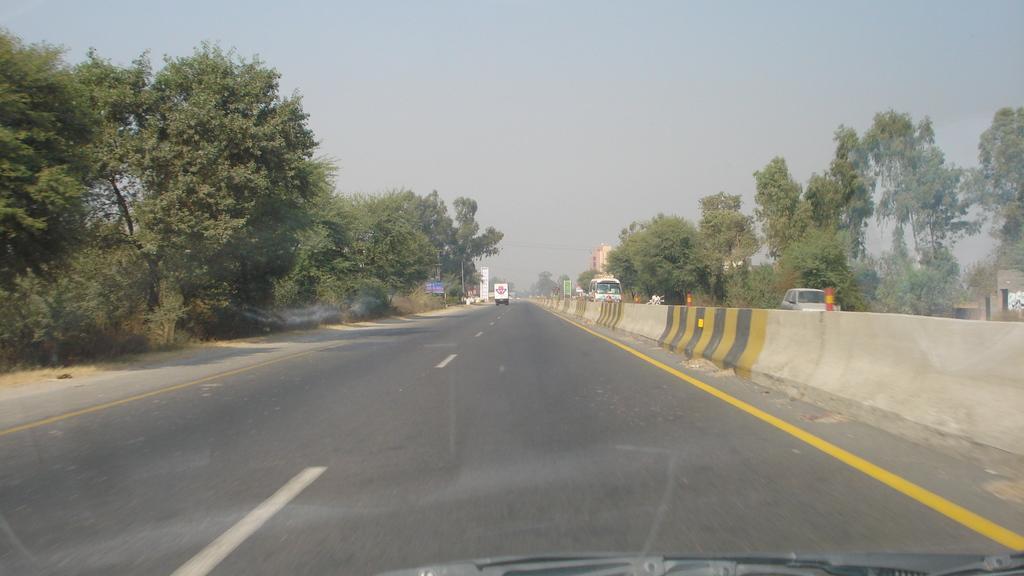Describe this image in one or two sentences. It's a road in the middle of an image on either side there are trees and a bus is coming opposite to us on the road and it's a sky at the top. 